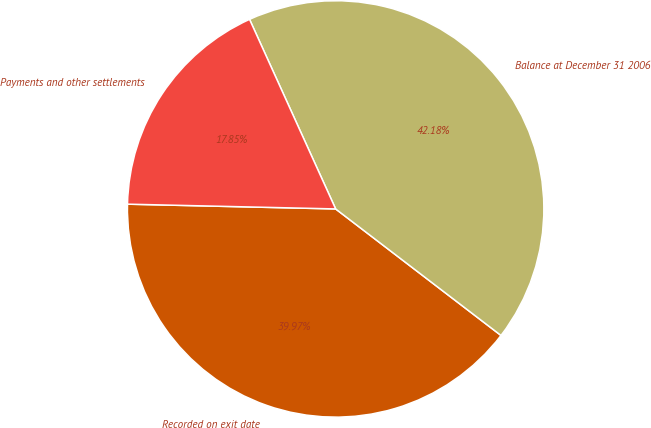Convert chart. <chart><loc_0><loc_0><loc_500><loc_500><pie_chart><fcel>Recorded on exit date<fcel>Balance at December 31 2006<fcel>Payments and other settlements<nl><fcel>39.97%<fcel>42.18%<fcel>17.85%<nl></chart> 